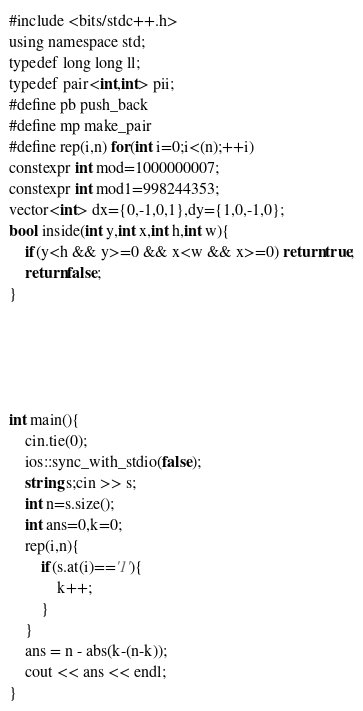Convert code to text. <code><loc_0><loc_0><loc_500><loc_500><_Go_>#include <bits/stdc++.h>
using namespace std;
typedef long long ll;
typedef pair<int,int> pii;
#define pb push_back
#define mp make_pair
#define rep(i,n) for(int i=0;i<(n);++i)
constexpr int mod=1000000007;
constexpr int mod1=998244353;
vector<int> dx={0,-1,0,1},dy={1,0,-1,0};
bool inside(int y,int x,int h,int w){
	if(y<h && y>=0 && x<w && x>=0) return true;
	return false;
}





int main(){
	cin.tie(0);
	ios::sync_with_stdio(false);
	string s;cin >> s;
	int n=s.size();
	int ans=0,k=0;
	rep(i,n){
		if(s.at(i)=='1'){
			k++;
		}
	}
	ans = n - abs(k-(n-k));
	cout << ans << endl;
}
</code> 